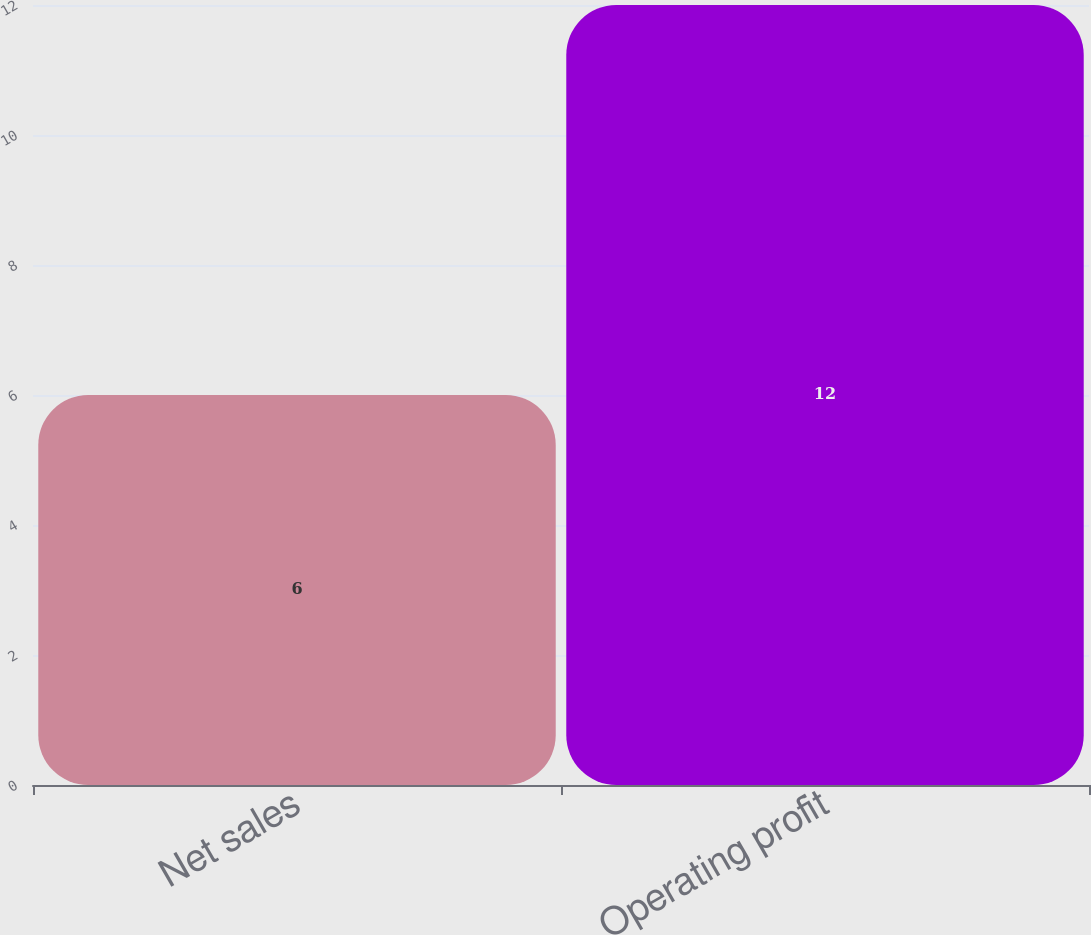<chart> <loc_0><loc_0><loc_500><loc_500><bar_chart><fcel>Net sales<fcel>Operating profit<nl><fcel>6<fcel>12<nl></chart> 